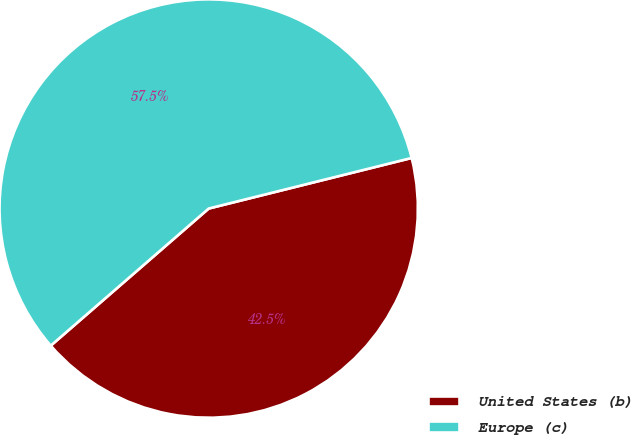Convert chart. <chart><loc_0><loc_0><loc_500><loc_500><pie_chart><fcel>United States (b)<fcel>Europe (c)<nl><fcel>42.51%<fcel>57.49%<nl></chart> 